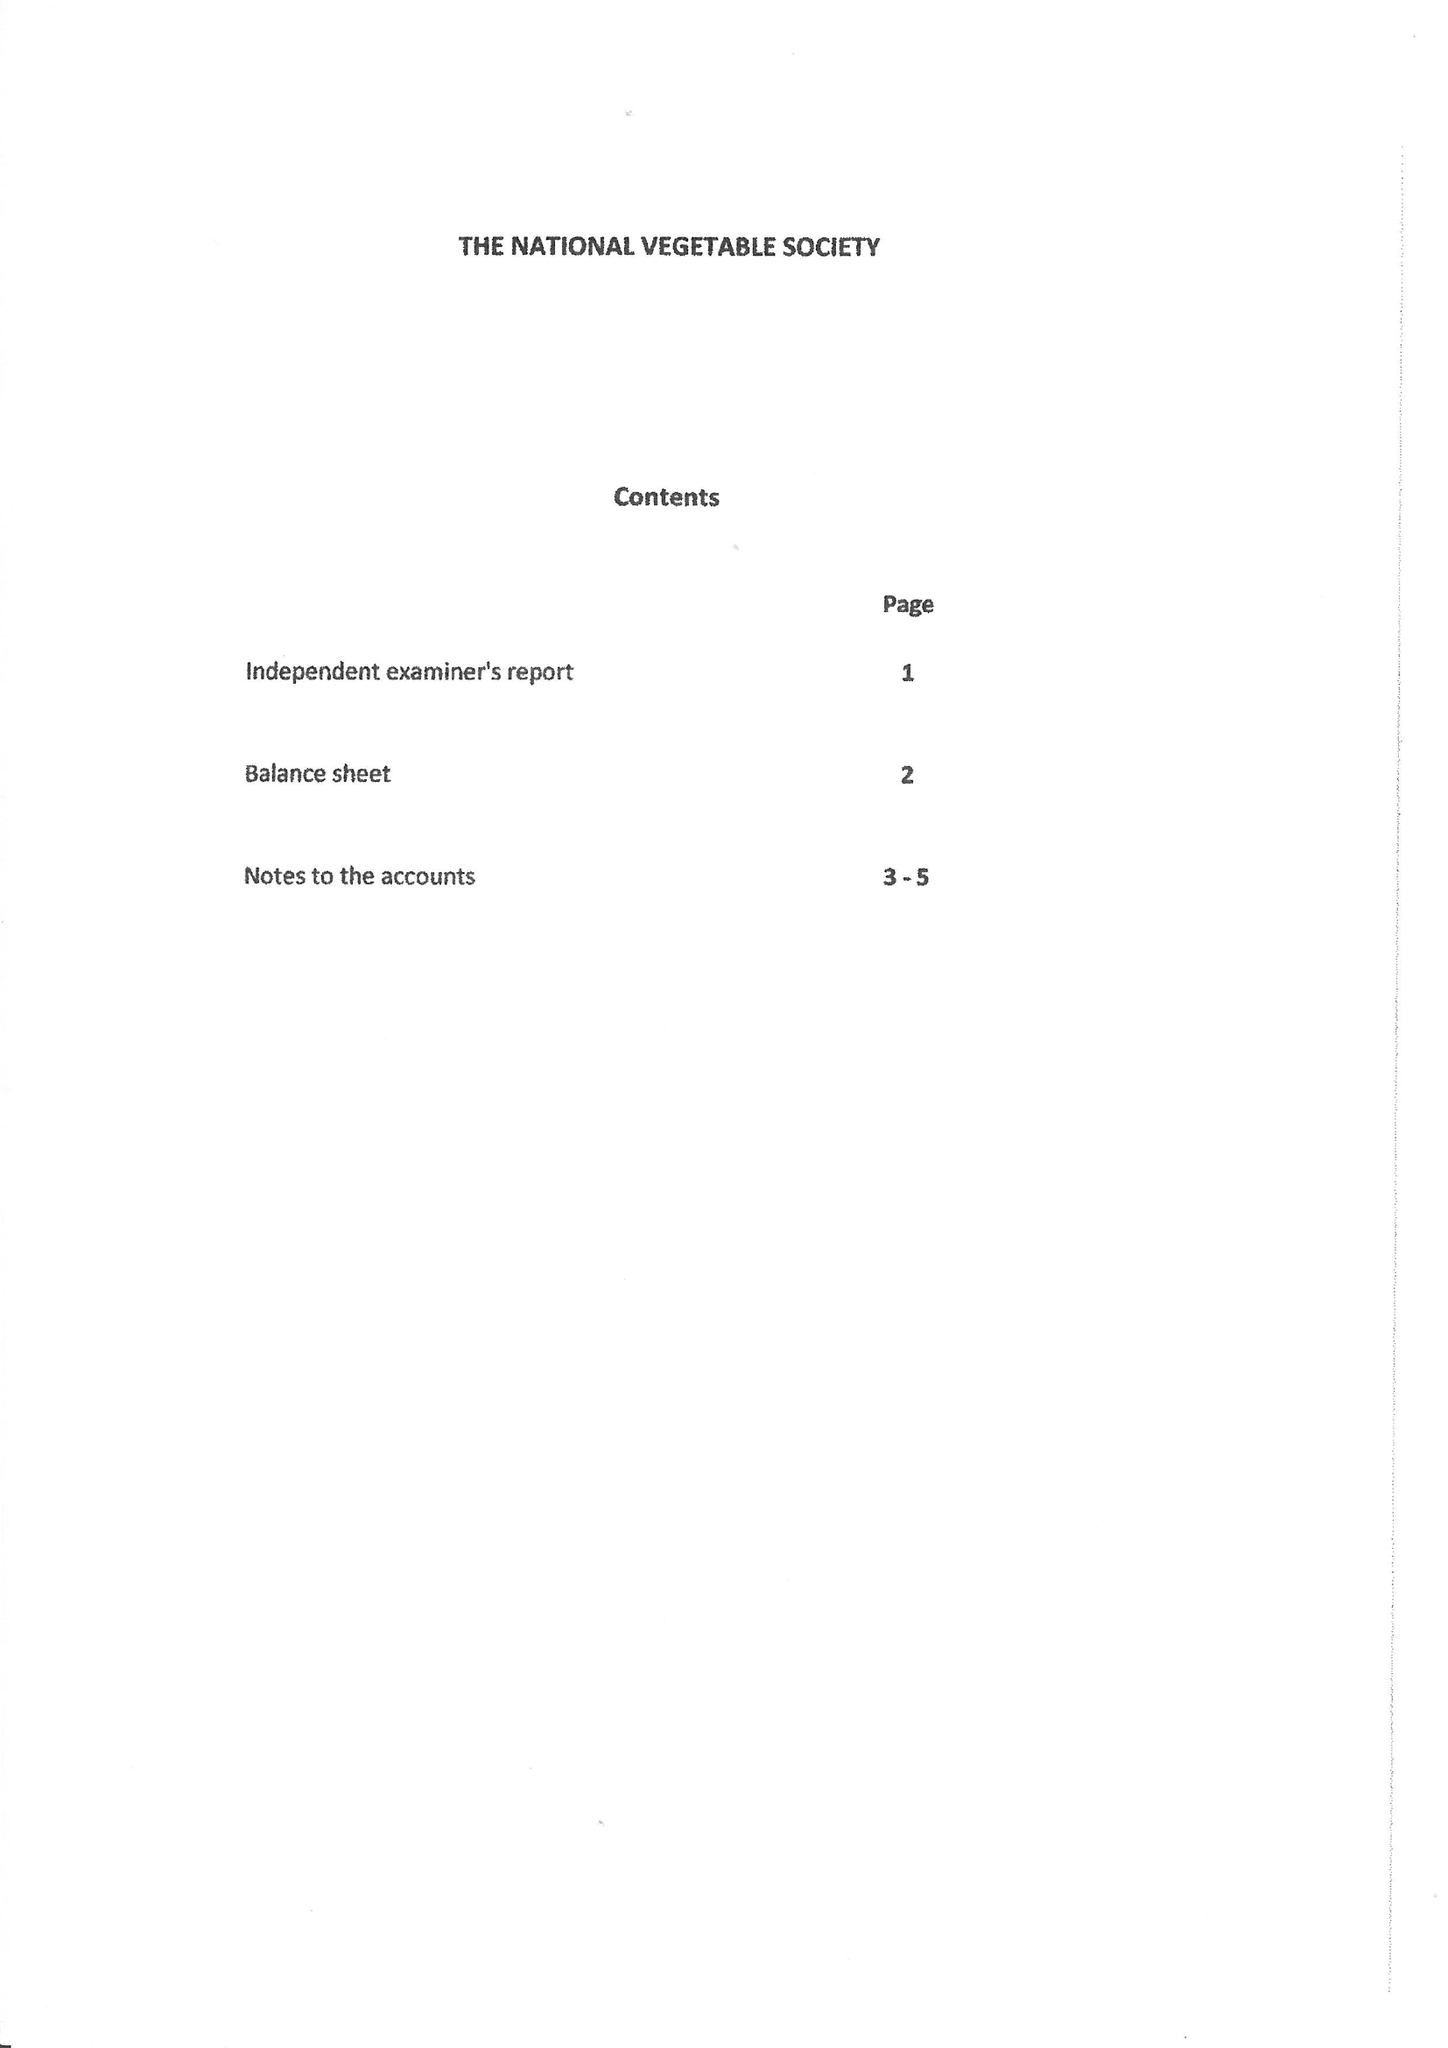What is the value for the charity_number?
Answer the question using a single word or phrase. 1088979 